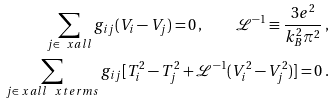Convert formula to latex. <formula><loc_0><loc_0><loc_500><loc_500>\sum _ { j \in \ x a l l } g _ { i j } ( V _ { i } - V _ { j } ) = 0 \, , \quad \mathcal { L } ^ { - 1 } \equiv \frac { 3 e ^ { 2 } } { k _ { B } ^ { 2 } \pi ^ { 2 } } \, , \\ \sum _ { j \in \ x a l l \ \ x t e r m s } g _ { i j } [ T _ { i } ^ { 2 } - T _ { j } ^ { 2 } + \mathcal { L } ^ { - 1 } ( V _ { i } ^ { 2 } - V _ { j } ^ { 2 } ) ] = 0 \, .</formula> 